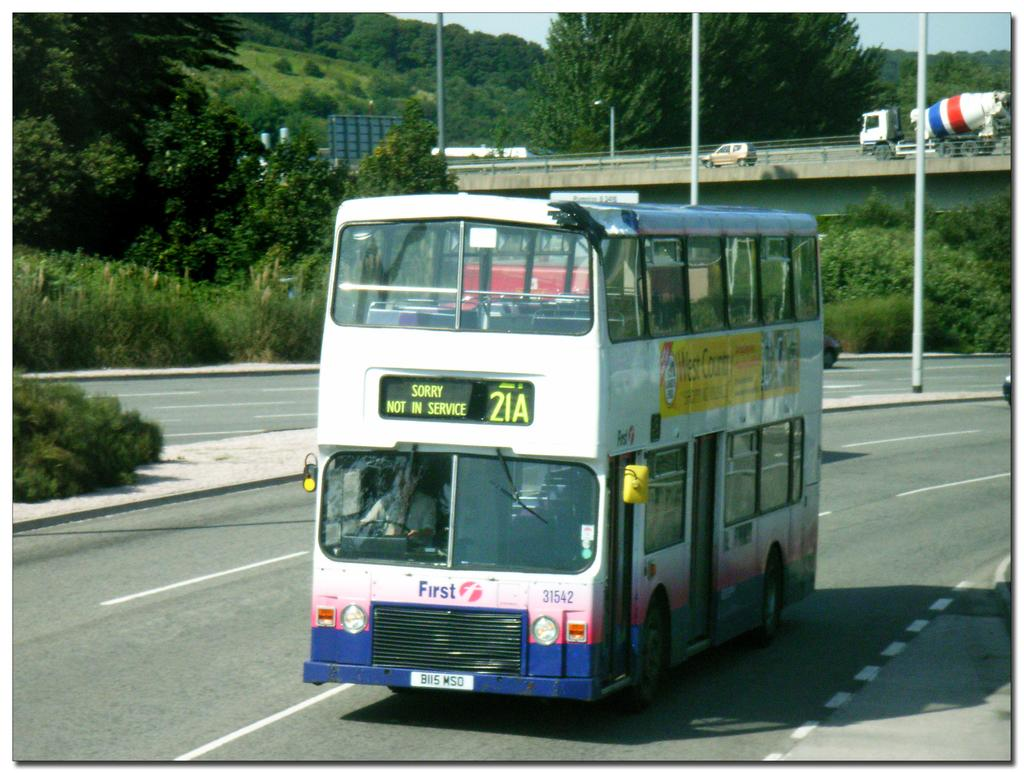<image>
Relay a brief, clear account of the picture shown. A bus moving down the street with the number 21A on it 